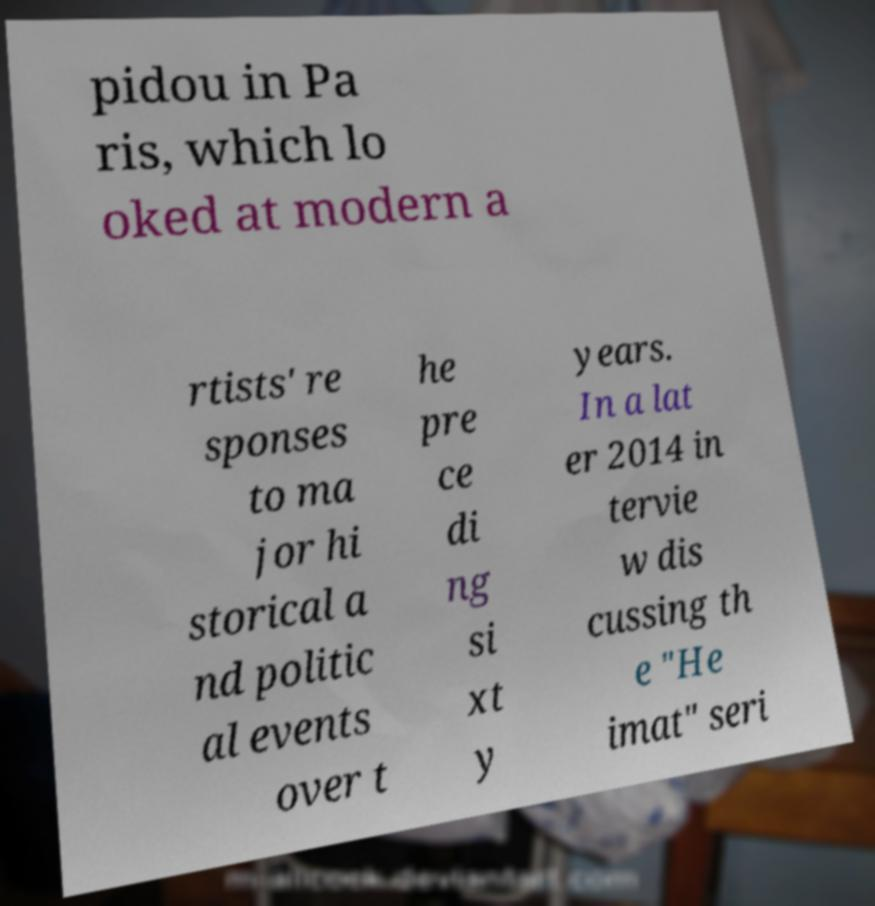Could you extract and type out the text from this image? pidou in Pa ris, which lo oked at modern a rtists' re sponses to ma jor hi storical a nd politic al events over t he pre ce di ng si xt y years. In a lat er 2014 in tervie w dis cussing th e "He imat" seri 